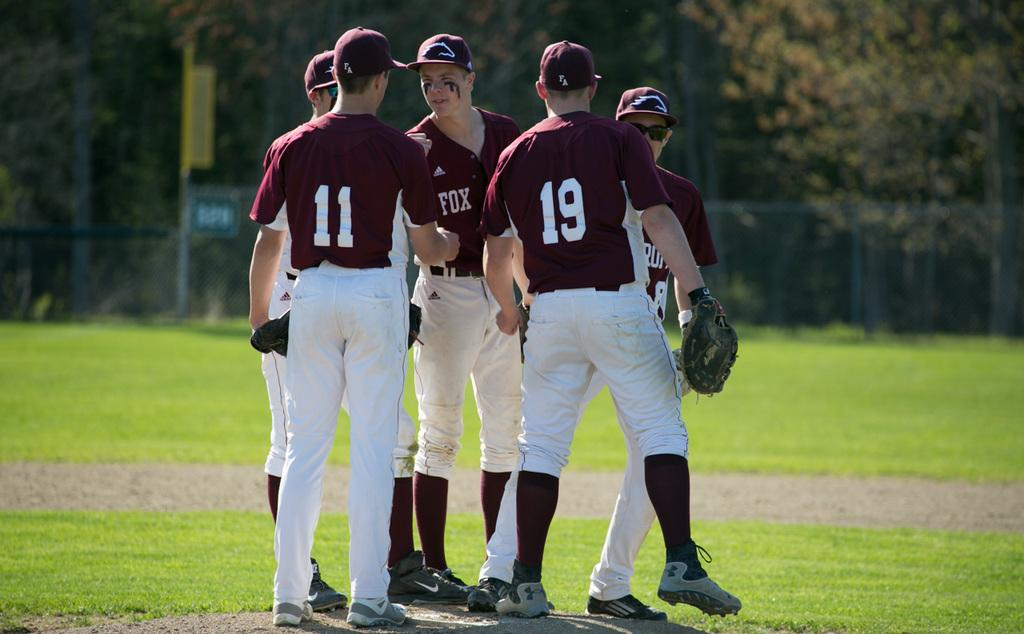<image>
Write a terse but informative summary of the picture. A group of five baseball players wearing Adidas maroon jerseys are huddled on a field. 